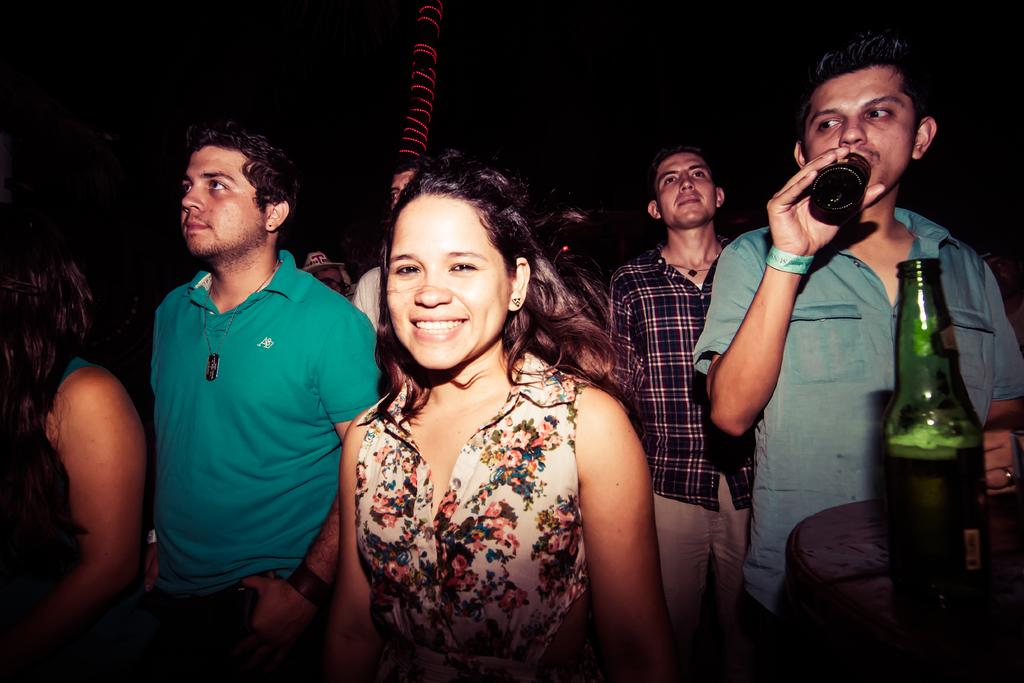What is happening in the image? There are people standing in the image. Can you describe what one of the people is holding? A person is holding a bottle in the image. Where is the green color bottle located in the image? There is a green color bottle on the right side of the image. How many frogs are sitting on the ship in the image? There are no frogs or ships present in the image. 